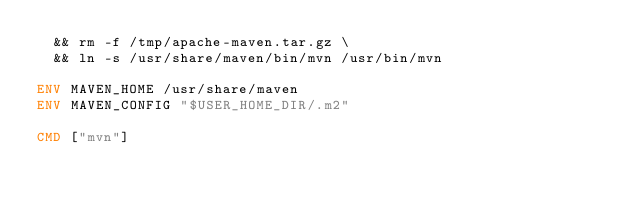Convert code to text. <code><loc_0><loc_0><loc_500><loc_500><_Dockerfile_>  && rm -f /tmp/apache-maven.tar.gz \
  && ln -s /usr/share/maven/bin/mvn /usr/bin/mvn

ENV MAVEN_HOME /usr/share/maven
ENV MAVEN_CONFIG "$USER_HOME_DIR/.m2"

CMD ["mvn"]</code> 